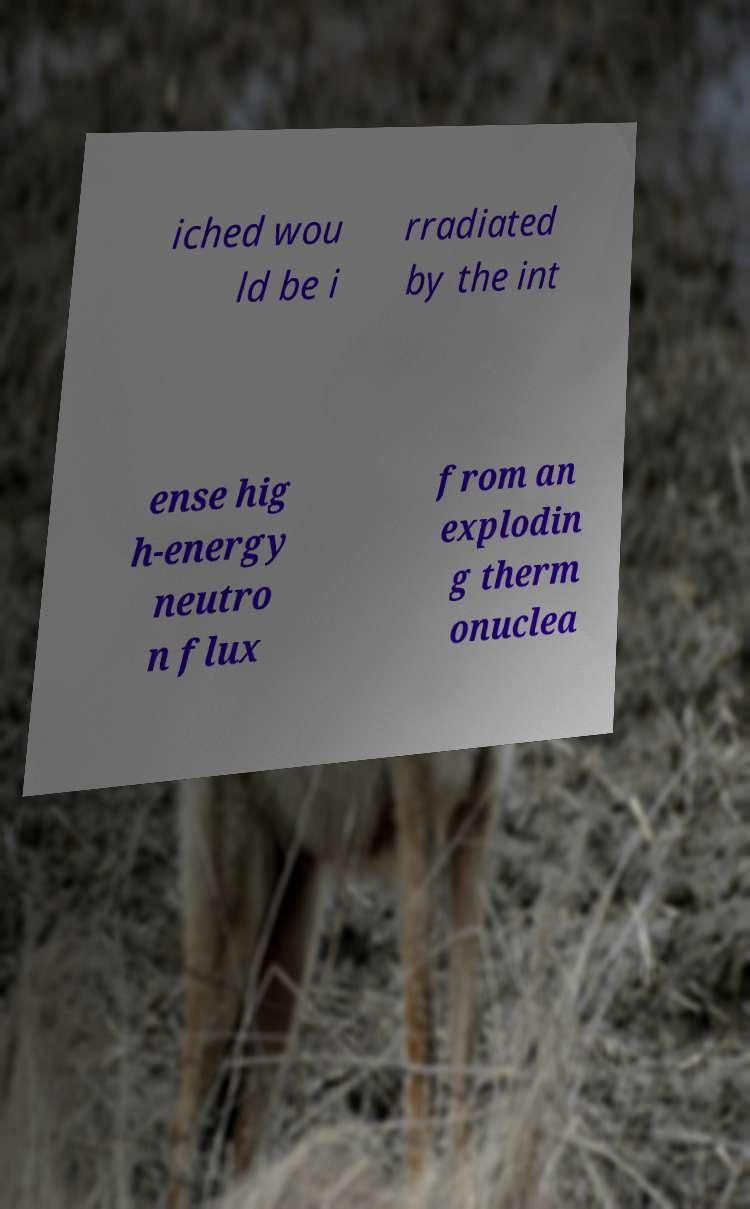Could you assist in decoding the text presented in this image and type it out clearly? iched wou ld be i rradiated by the int ense hig h-energy neutro n flux from an explodin g therm onuclea 